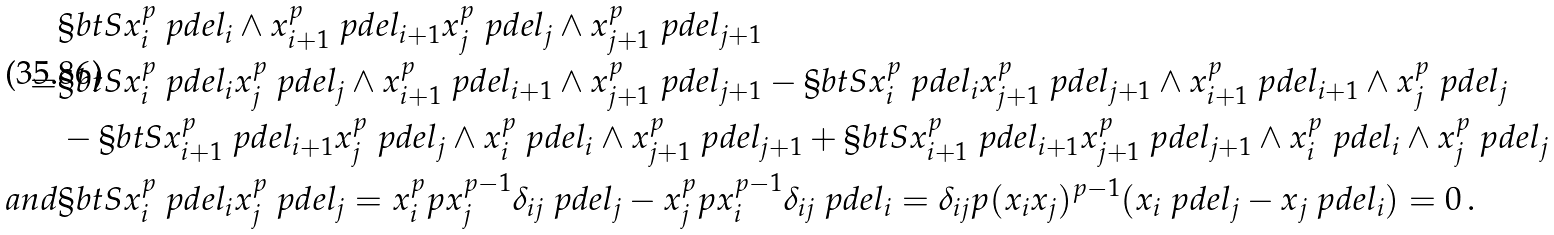Convert formula to latex. <formula><loc_0><loc_0><loc_500><loc_500>& \S b t S { x _ { i } ^ { p } \ p d e l _ { i } \wedge x _ { i + 1 } ^ { p } \ p d e l _ { i + 1 } } { x _ { j } ^ { p } \ p d e l _ { j } \wedge x _ { j + 1 } ^ { p } \ p d e l _ { j + 1 } } \\ = & \S b t S { x _ { i } ^ { p } \ p d e l _ { i } } { x _ { j } ^ { p } \ p d e l _ { j } } \wedge x _ { i + 1 } ^ { p } \ p d e l _ { i + 1 } \wedge x _ { j + 1 } ^ { p } \ p d e l _ { j + 1 } - \S b t S { x _ { i } ^ { p } \ p d e l _ { i } } { x _ { j + 1 } ^ { p } \ p d e l _ { j + 1 } } \wedge x _ { i + 1 } ^ { p } \ p d e l _ { i + 1 } \wedge x _ { j } ^ { p } \ p d e l _ { j } \\ & - \S b t S { x _ { i + 1 } ^ { p } \ p d e l _ { i + 1 } } { x _ { j } ^ { p } \ p d e l _ { j } } \wedge x _ { i } ^ { p } \ p d e l _ { i } \wedge x _ { j + 1 } ^ { p } \ p d e l _ { j + 1 } + \S b t S { x _ { i + 1 } ^ { p } \ p d e l _ { i + 1 } } { x _ { j + 1 } ^ { p } \ p d e l _ { j + 1 } } \wedge x _ { i } ^ { p } \ p d e l _ { i } \wedge x _ { j } ^ { p } \ p d e l _ { j } \\ { a n d } & \S b t S { x _ { i } ^ { p } \ p d e l _ { i } } { x _ { j } ^ { p } \ p d e l _ { j } } = x _ { i } ^ { p } p x _ { j } ^ { p - 1 } \delta _ { i j } \ p d e l _ { j } - x _ { j } ^ { p } p x _ { i } ^ { p - 1 } \delta _ { i j } \ p d e l _ { i } = \delta _ { i j } p ( x _ { i } x _ { j } ) ^ { p - 1 } ( x _ { i } \ p d e l _ { j } - x _ { j } \ p d e l _ { i } ) = 0 \, .</formula> 